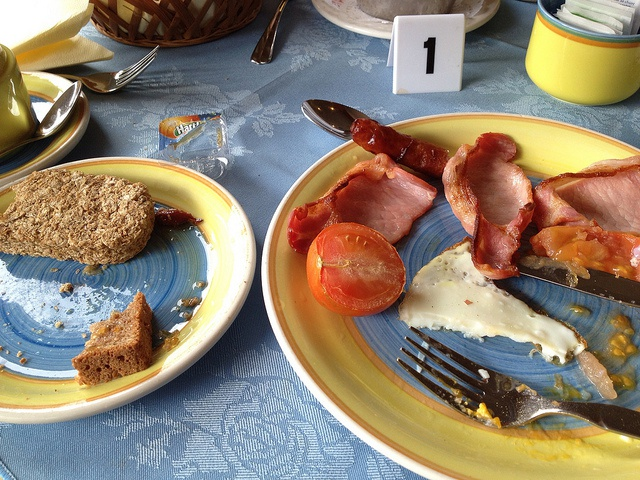Describe the objects in this image and their specific colors. I can see dining table in gray, black, ivory, and brown tones, bowl in white, khaki, and olive tones, cup in white, khaki, and olive tones, fork in white, black, gray, and maroon tones, and knife in white, black, maroon, and gray tones in this image. 